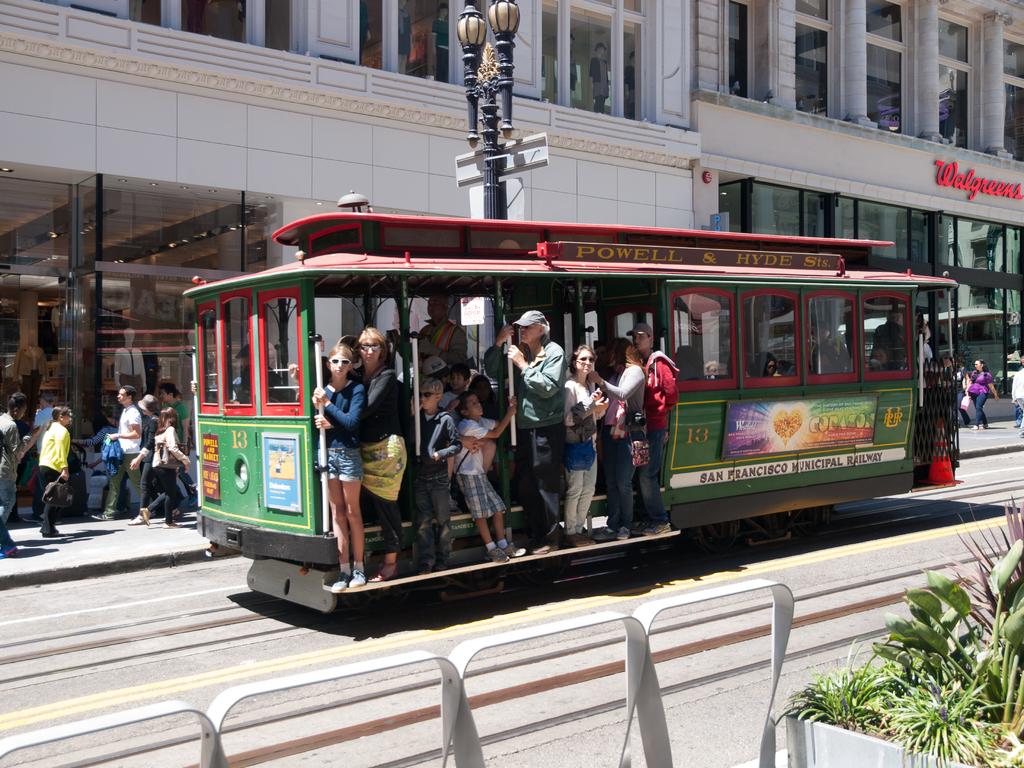What is the name of the pharmacy on the far right?
Your answer should be compact. Walgreens. 